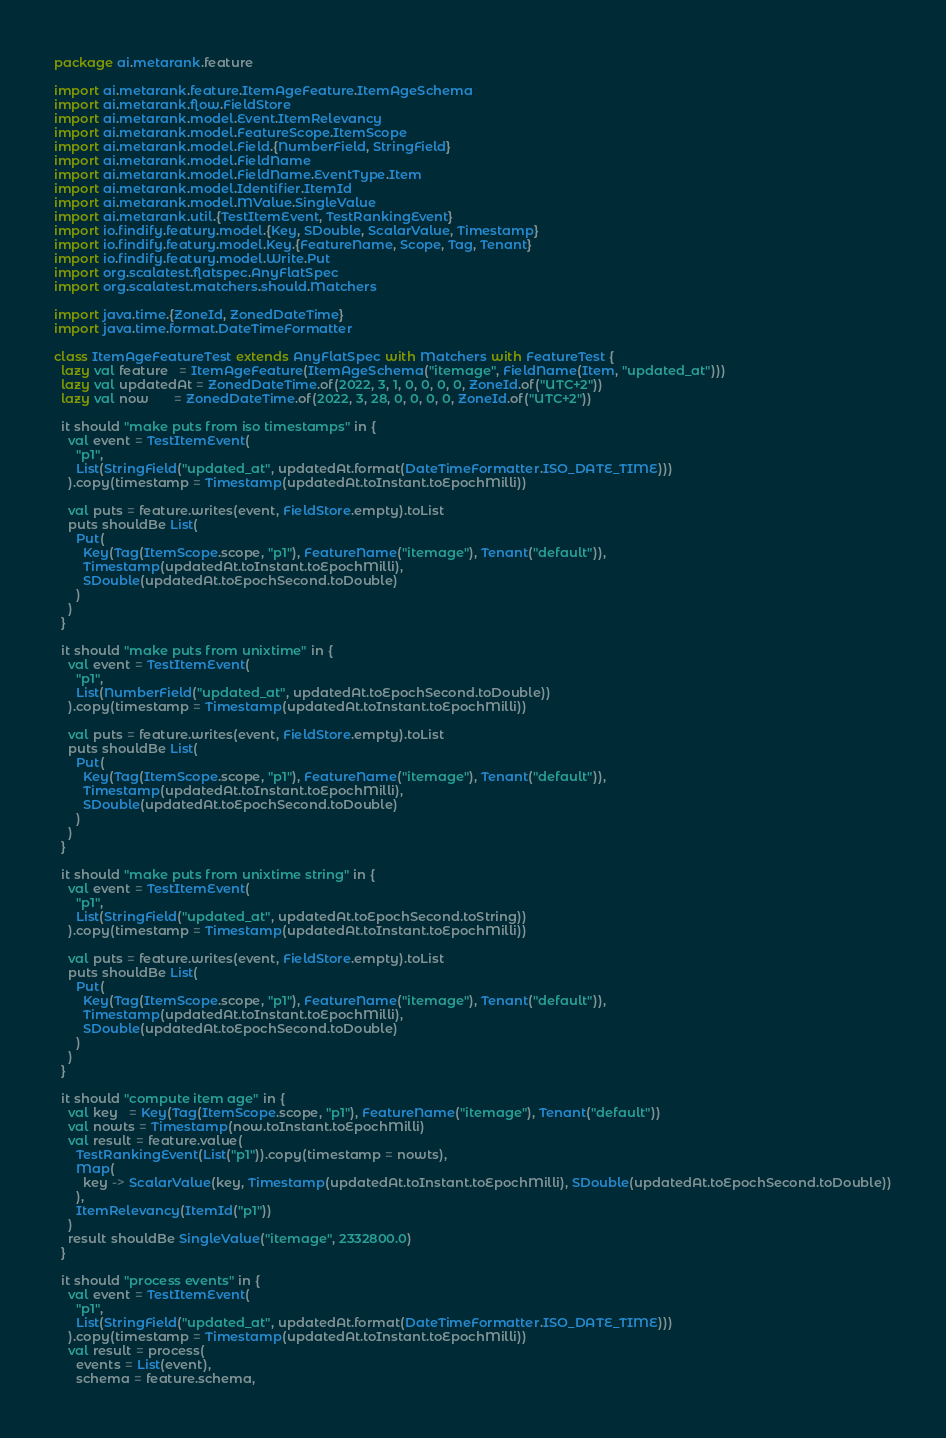Convert code to text. <code><loc_0><loc_0><loc_500><loc_500><_Scala_>package ai.metarank.feature

import ai.metarank.feature.ItemAgeFeature.ItemAgeSchema
import ai.metarank.flow.FieldStore
import ai.metarank.model.Event.ItemRelevancy
import ai.metarank.model.FeatureScope.ItemScope
import ai.metarank.model.Field.{NumberField, StringField}
import ai.metarank.model.FieldName
import ai.metarank.model.FieldName.EventType.Item
import ai.metarank.model.Identifier.ItemId
import ai.metarank.model.MValue.SingleValue
import ai.metarank.util.{TestItemEvent, TestRankingEvent}
import io.findify.featury.model.{Key, SDouble, ScalarValue, Timestamp}
import io.findify.featury.model.Key.{FeatureName, Scope, Tag, Tenant}
import io.findify.featury.model.Write.Put
import org.scalatest.flatspec.AnyFlatSpec
import org.scalatest.matchers.should.Matchers

import java.time.{ZoneId, ZonedDateTime}
import java.time.format.DateTimeFormatter

class ItemAgeFeatureTest extends AnyFlatSpec with Matchers with FeatureTest {
  lazy val feature   = ItemAgeFeature(ItemAgeSchema("itemage", FieldName(Item, "updated_at")))
  lazy val updatedAt = ZonedDateTime.of(2022, 3, 1, 0, 0, 0, 0, ZoneId.of("UTC+2"))
  lazy val now       = ZonedDateTime.of(2022, 3, 28, 0, 0, 0, 0, ZoneId.of("UTC+2"))

  it should "make puts from iso timestamps" in {
    val event = TestItemEvent(
      "p1",
      List(StringField("updated_at", updatedAt.format(DateTimeFormatter.ISO_DATE_TIME)))
    ).copy(timestamp = Timestamp(updatedAt.toInstant.toEpochMilli))

    val puts = feature.writes(event, FieldStore.empty).toList
    puts shouldBe List(
      Put(
        Key(Tag(ItemScope.scope, "p1"), FeatureName("itemage"), Tenant("default")),
        Timestamp(updatedAt.toInstant.toEpochMilli),
        SDouble(updatedAt.toEpochSecond.toDouble)
      )
    )
  }

  it should "make puts from unixtime" in {
    val event = TestItemEvent(
      "p1",
      List(NumberField("updated_at", updatedAt.toEpochSecond.toDouble))
    ).copy(timestamp = Timestamp(updatedAt.toInstant.toEpochMilli))

    val puts = feature.writes(event, FieldStore.empty).toList
    puts shouldBe List(
      Put(
        Key(Tag(ItemScope.scope, "p1"), FeatureName("itemage"), Tenant("default")),
        Timestamp(updatedAt.toInstant.toEpochMilli),
        SDouble(updatedAt.toEpochSecond.toDouble)
      )
    )
  }

  it should "make puts from unixtime string" in {
    val event = TestItemEvent(
      "p1",
      List(StringField("updated_at", updatedAt.toEpochSecond.toString))
    ).copy(timestamp = Timestamp(updatedAt.toInstant.toEpochMilli))

    val puts = feature.writes(event, FieldStore.empty).toList
    puts shouldBe List(
      Put(
        Key(Tag(ItemScope.scope, "p1"), FeatureName("itemage"), Tenant("default")),
        Timestamp(updatedAt.toInstant.toEpochMilli),
        SDouble(updatedAt.toEpochSecond.toDouble)
      )
    )
  }

  it should "compute item age" in {
    val key   = Key(Tag(ItemScope.scope, "p1"), FeatureName("itemage"), Tenant("default"))
    val nowts = Timestamp(now.toInstant.toEpochMilli)
    val result = feature.value(
      TestRankingEvent(List("p1")).copy(timestamp = nowts),
      Map(
        key -> ScalarValue(key, Timestamp(updatedAt.toInstant.toEpochMilli), SDouble(updatedAt.toEpochSecond.toDouble))
      ),
      ItemRelevancy(ItemId("p1"))
    )
    result shouldBe SingleValue("itemage", 2332800.0)
  }

  it should "process events" in {
    val event = TestItemEvent(
      "p1",
      List(StringField("updated_at", updatedAt.format(DateTimeFormatter.ISO_DATE_TIME)))
    ).copy(timestamp = Timestamp(updatedAt.toInstant.toEpochMilli))
    val result = process(
      events = List(event),
      schema = feature.schema,</code> 